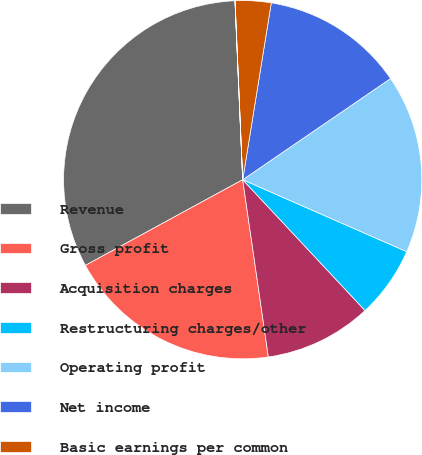Convert chart. <chart><loc_0><loc_0><loc_500><loc_500><pie_chart><fcel>Revenue � � � � � � � � � � �<fcel>Gross profit � � � � � � � � �<fcel>Acquisition charges � � � � �<fcel>Restructuring charges/other �<fcel>Operating profit� � � � � � �<fcel>Net income � � � � � � � � � �<fcel>Basic earnings per common<fcel>Diluted earnings per common<nl><fcel>32.25%<fcel>19.35%<fcel>9.68%<fcel>6.45%<fcel>16.13%<fcel>12.9%<fcel>3.23%<fcel>0.01%<nl></chart> 